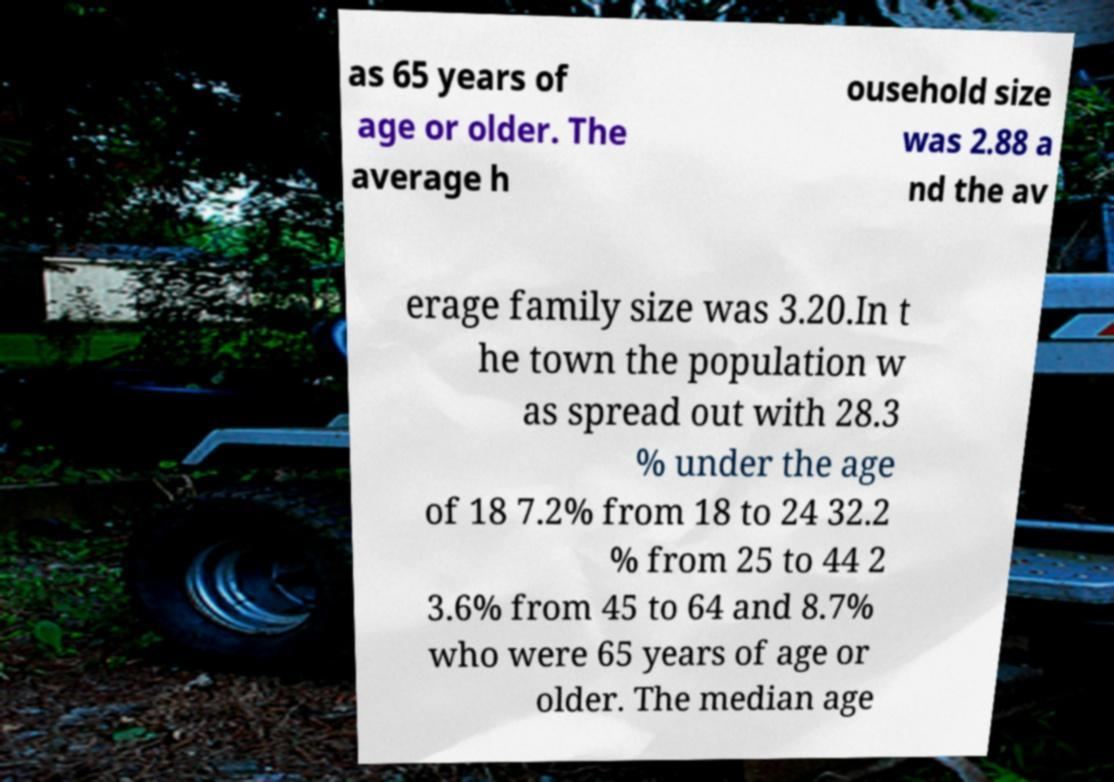Please read and relay the text visible in this image. What does it say? as 65 years of age or older. The average h ousehold size was 2.88 a nd the av erage family size was 3.20.In t he town the population w as spread out with 28.3 % under the age of 18 7.2% from 18 to 24 32.2 % from 25 to 44 2 3.6% from 45 to 64 and 8.7% who were 65 years of age or older. The median age 